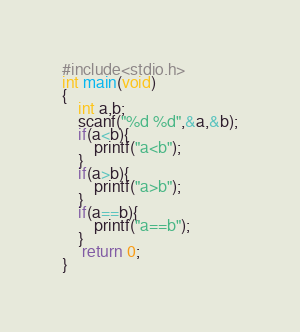<code> <loc_0><loc_0><loc_500><loc_500><_C_>#include<stdio.h>
int main(void)
{
	int a,b;
	scanf("%d %d",&a,&b);
	if(a<b){
		printf("a<b");
	}
	if(a>b){
		printf("a>b");
	}
	if(a==b){
		printf("a==b");
	}
	 return 0;
}</code> 